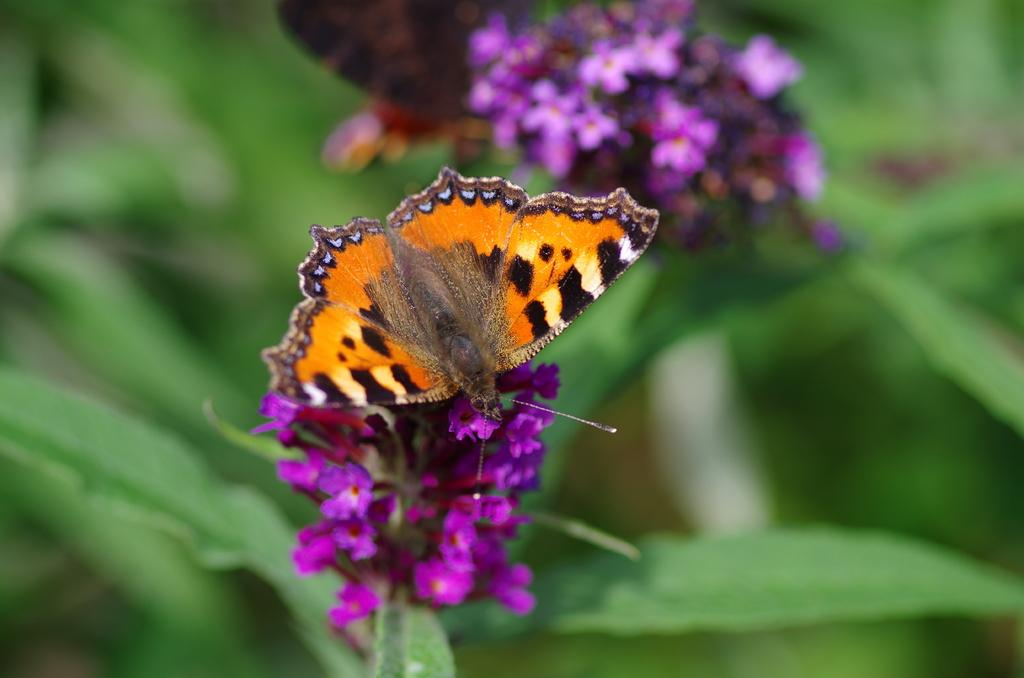What type of insect is present in the image? There is a butterfly in the image. What colors can be seen on the butterfly? The butterfly has brown and black colors. What is the butterfly resting on in the image? The butterfly is on pink color flowers. What other floral elements can be seen in the image? There are additional flowers visible in the background of the image. Is there a cup being used to catch rainwater during the rainstorm in the image? There is no cup or rainstorm present in the image; it features a butterfly on pink flowers with additional flowers in the background. 